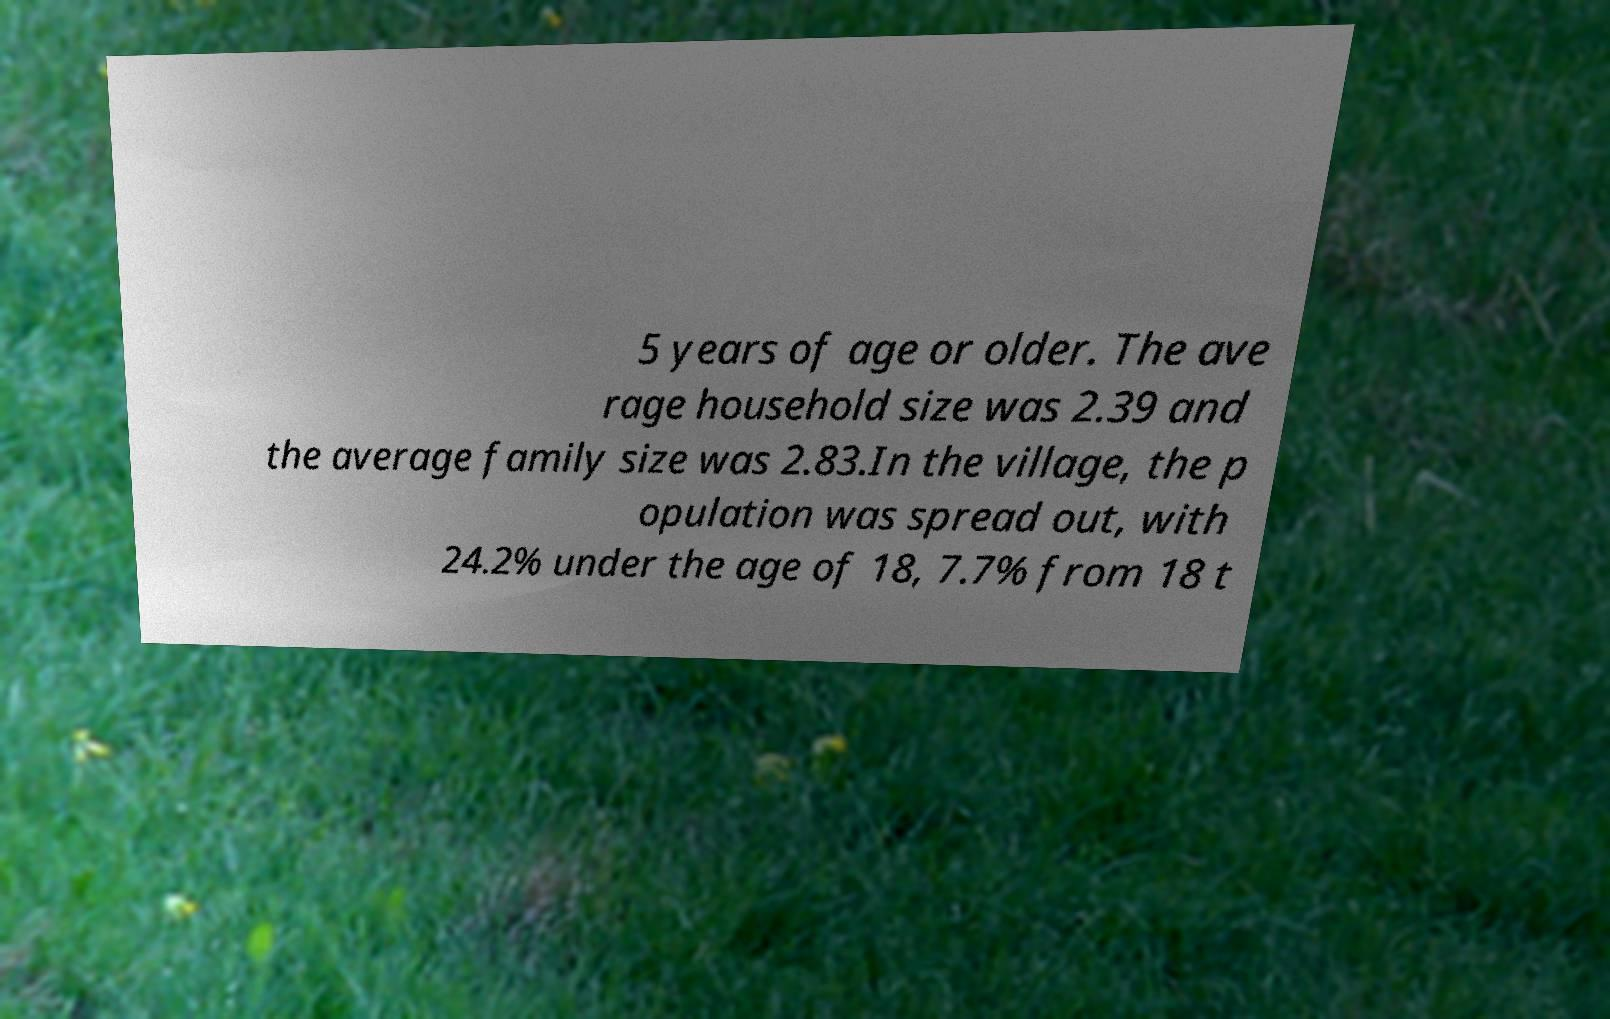Could you assist in decoding the text presented in this image and type it out clearly? 5 years of age or older. The ave rage household size was 2.39 and the average family size was 2.83.In the village, the p opulation was spread out, with 24.2% under the age of 18, 7.7% from 18 t 